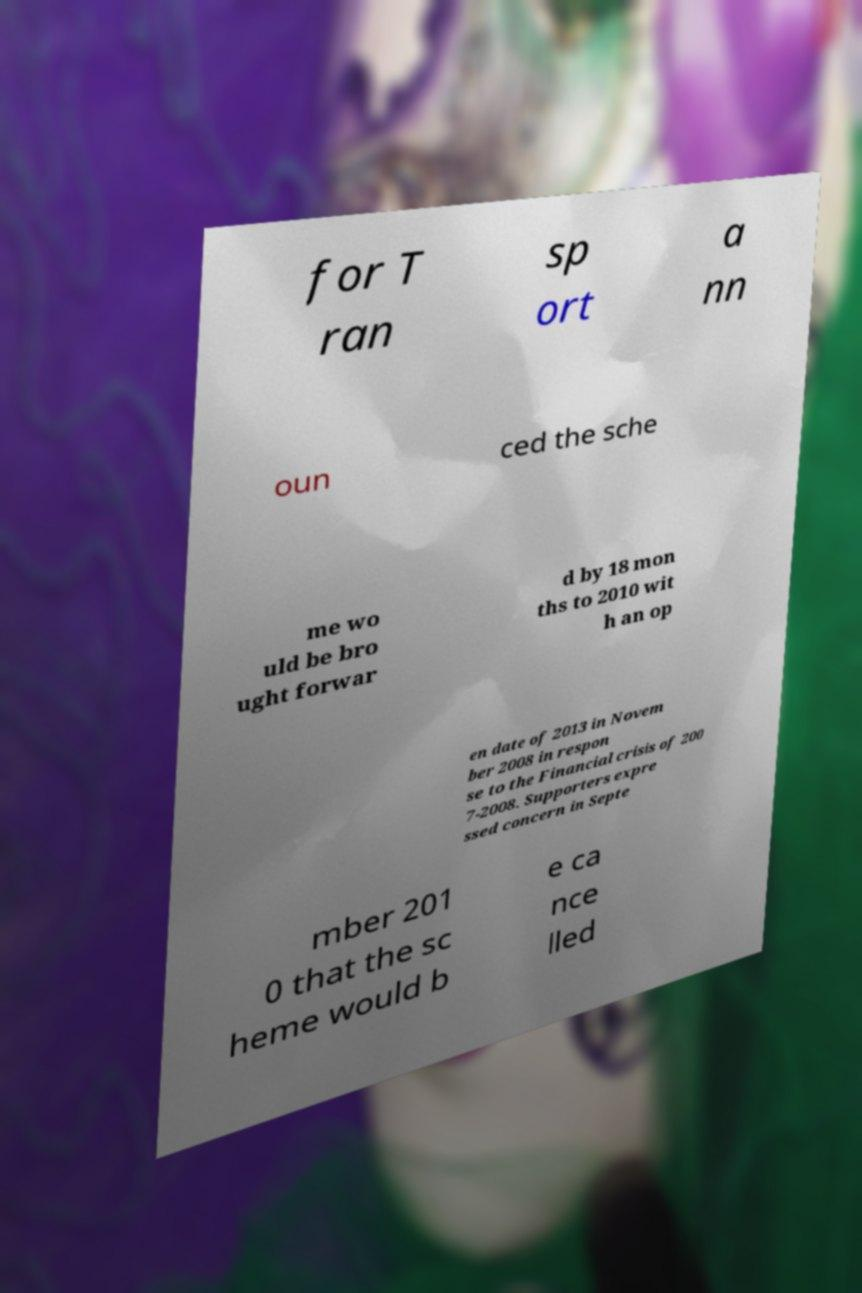For documentation purposes, I need the text within this image transcribed. Could you provide that? for T ran sp ort a nn oun ced the sche me wo uld be bro ught forwar d by 18 mon ths to 2010 wit h an op en date of 2013 in Novem ber 2008 in respon se to the Financial crisis of 200 7-2008. Supporters expre ssed concern in Septe mber 201 0 that the sc heme would b e ca nce lled 